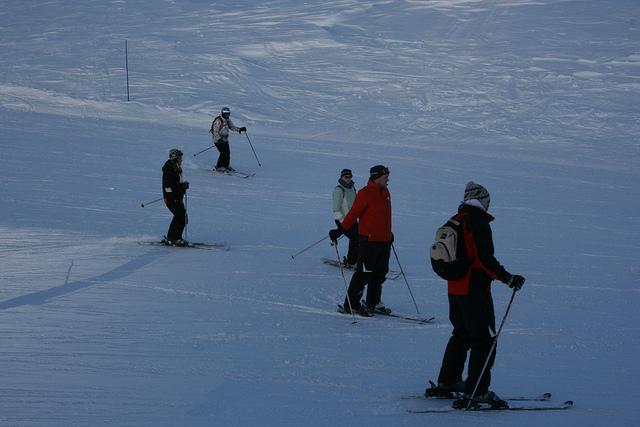Are any skiers casting shadows?
Answer briefly. Yes. How many people are in the photo?
Keep it brief. 5. Is the skier alone?
Concise answer only. No. What season is it?
Concise answer only. Winter. Is the man wearing swimming trunks?
Answer briefly. No. How many snow skis do you see?
Give a very brief answer. 10. What is the person doing?
Keep it brief. Skiing. Is the child wearing protective gear?
Short answer required. Yes. Where is a white helmet?
Keep it brief. Nowhere. Is it daytime or nighttime?
Be succinct. Daytime. Could this be the last run of the day?
Quick response, please. Yes. Are these people holding ski poles?
Quick response, please. Yes. 